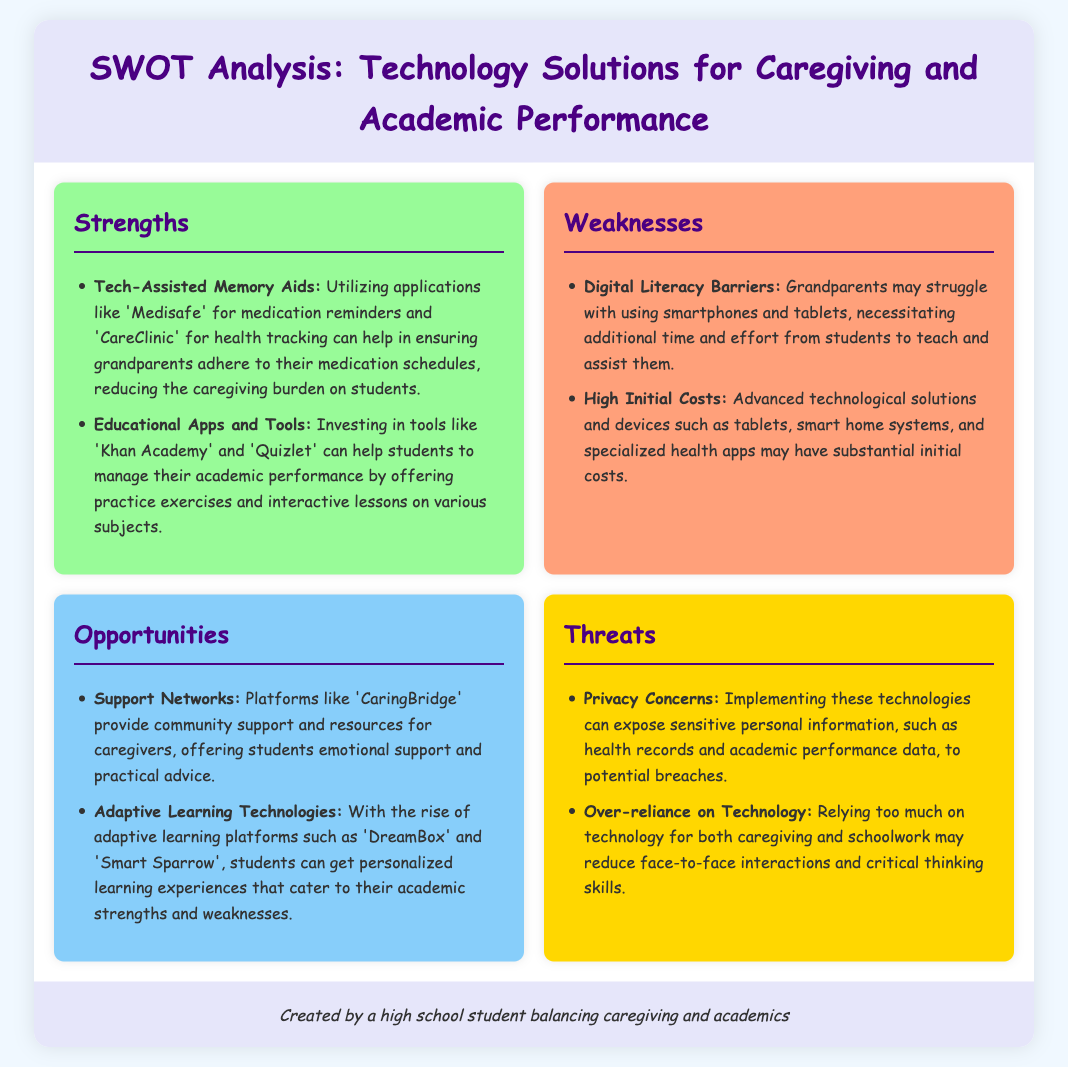what is one example of a tech-assisted memory aid? The document mentions 'Medisafe' as an application for medication reminders.
Answer: Medisafe which platform offers personalized learning experiences? The document refers to 'DreamBox' as an adaptive learning platform for personalized experiences.
Answer: DreamBox what is a weakness related to digital literacy? The document states that grandparents may struggle with using smartphones and tablets.
Answer: Struggle with smartphones name one opportunity that provides community support for caregivers. The document includes 'CaringBridge' as a platform that offers support and resources for caregivers.
Answer: CaringBridge what is a threat related to privacy? The document highlights the concern of exposing sensitive personal information to potential breaches.
Answer: Privacy concerns how many strengths are mentioned in the document? The document lists two strengths under the strengths section.
Answer: Two 